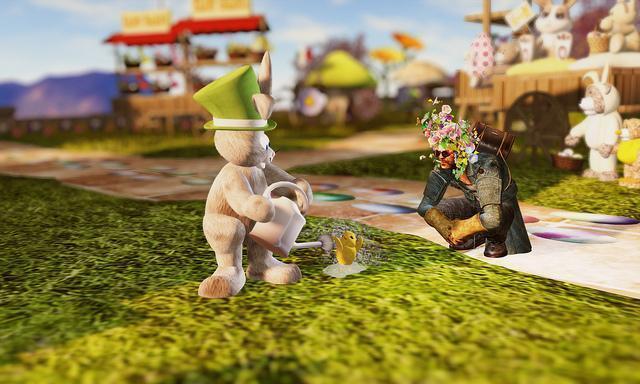How many people can you see?
Give a very brief answer. 1. How many train tracks are empty?
Give a very brief answer. 0. 